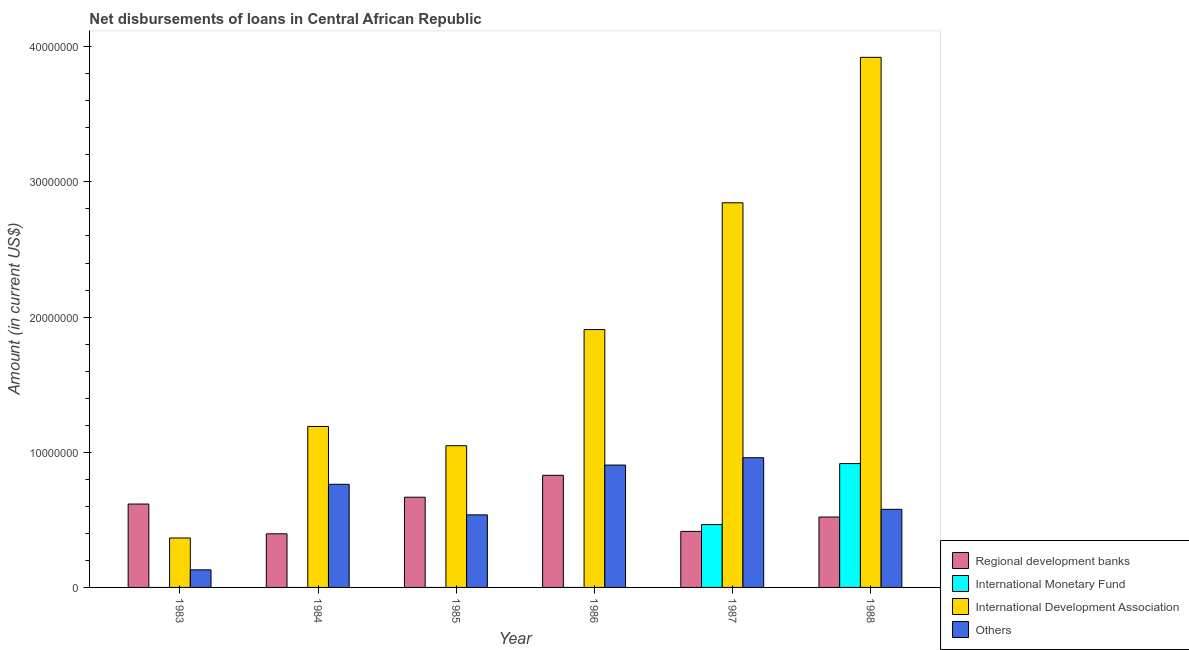Are the number of bars per tick equal to the number of legend labels?
Your answer should be very brief. No. Are the number of bars on each tick of the X-axis equal?
Ensure brevity in your answer.  No. How many bars are there on the 4th tick from the right?
Offer a terse response. 3. In how many cases, is the number of bars for a given year not equal to the number of legend labels?
Provide a succinct answer. 4. What is the amount of loan disimbursed by regional development banks in 1985?
Make the answer very short. 6.67e+06. Across all years, what is the maximum amount of loan disimbursed by other organisations?
Make the answer very short. 9.60e+06. In which year was the amount of loan disimbursed by other organisations maximum?
Your answer should be compact. 1987. What is the total amount of loan disimbursed by international monetary fund in the graph?
Ensure brevity in your answer.  1.38e+07. What is the difference between the amount of loan disimbursed by other organisations in 1984 and that in 1987?
Offer a terse response. -1.97e+06. What is the difference between the amount of loan disimbursed by international monetary fund in 1986 and the amount of loan disimbursed by regional development banks in 1987?
Provide a short and direct response. -4.65e+06. What is the average amount of loan disimbursed by international development association per year?
Keep it short and to the point. 1.88e+07. In the year 1985, what is the difference between the amount of loan disimbursed by other organisations and amount of loan disimbursed by regional development banks?
Ensure brevity in your answer.  0. In how many years, is the amount of loan disimbursed by international development association greater than 38000000 US$?
Make the answer very short. 1. What is the ratio of the amount of loan disimbursed by other organisations in 1984 to that in 1985?
Offer a terse response. 1.42. Is the amount of loan disimbursed by regional development banks in 1986 less than that in 1987?
Give a very brief answer. No. Is the difference between the amount of loan disimbursed by regional development banks in 1983 and 1988 greater than the difference between the amount of loan disimbursed by other organisations in 1983 and 1988?
Offer a very short reply. No. What is the difference between the highest and the second highest amount of loan disimbursed by regional development banks?
Provide a succinct answer. 1.62e+06. What is the difference between the highest and the lowest amount of loan disimbursed by international development association?
Your answer should be compact. 3.56e+07. Is the sum of the amount of loan disimbursed by international development association in 1984 and 1988 greater than the maximum amount of loan disimbursed by other organisations across all years?
Your answer should be very brief. Yes. How many bars are there?
Your response must be concise. 20. Are the values on the major ticks of Y-axis written in scientific E-notation?
Your answer should be compact. No. Does the graph contain grids?
Your response must be concise. No. Where does the legend appear in the graph?
Provide a short and direct response. Bottom right. What is the title of the graph?
Provide a succinct answer. Net disbursements of loans in Central African Republic. What is the label or title of the X-axis?
Give a very brief answer. Year. What is the label or title of the Y-axis?
Your response must be concise. Amount (in current US$). What is the Amount (in current US$) of Regional development banks in 1983?
Ensure brevity in your answer.  6.17e+06. What is the Amount (in current US$) of International Monetary Fund in 1983?
Your response must be concise. 0. What is the Amount (in current US$) of International Development Association in 1983?
Provide a succinct answer. 3.66e+06. What is the Amount (in current US$) of Others in 1983?
Your answer should be compact. 1.30e+06. What is the Amount (in current US$) in Regional development banks in 1984?
Offer a terse response. 3.97e+06. What is the Amount (in current US$) in International Development Association in 1984?
Make the answer very short. 1.19e+07. What is the Amount (in current US$) in Others in 1984?
Provide a succinct answer. 7.63e+06. What is the Amount (in current US$) in Regional development banks in 1985?
Your answer should be compact. 6.67e+06. What is the Amount (in current US$) in International Monetary Fund in 1985?
Ensure brevity in your answer.  0. What is the Amount (in current US$) of International Development Association in 1985?
Your answer should be very brief. 1.05e+07. What is the Amount (in current US$) in Others in 1985?
Provide a short and direct response. 5.37e+06. What is the Amount (in current US$) in Regional development banks in 1986?
Offer a very short reply. 8.30e+06. What is the Amount (in current US$) in International Development Association in 1986?
Make the answer very short. 1.91e+07. What is the Amount (in current US$) of Others in 1986?
Offer a terse response. 9.05e+06. What is the Amount (in current US$) in Regional development banks in 1987?
Make the answer very short. 4.15e+06. What is the Amount (in current US$) of International Monetary Fund in 1987?
Give a very brief answer. 4.65e+06. What is the Amount (in current US$) of International Development Association in 1987?
Give a very brief answer. 2.85e+07. What is the Amount (in current US$) of Others in 1987?
Provide a succinct answer. 9.60e+06. What is the Amount (in current US$) of Regional development banks in 1988?
Provide a succinct answer. 5.21e+06. What is the Amount (in current US$) of International Monetary Fund in 1988?
Your answer should be compact. 9.16e+06. What is the Amount (in current US$) of International Development Association in 1988?
Make the answer very short. 3.92e+07. What is the Amount (in current US$) in Others in 1988?
Offer a very short reply. 5.78e+06. Across all years, what is the maximum Amount (in current US$) in Regional development banks?
Offer a very short reply. 8.30e+06. Across all years, what is the maximum Amount (in current US$) in International Monetary Fund?
Your response must be concise. 9.16e+06. Across all years, what is the maximum Amount (in current US$) of International Development Association?
Give a very brief answer. 3.92e+07. Across all years, what is the maximum Amount (in current US$) in Others?
Provide a succinct answer. 9.60e+06. Across all years, what is the minimum Amount (in current US$) in Regional development banks?
Offer a terse response. 3.97e+06. Across all years, what is the minimum Amount (in current US$) of International Monetary Fund?
Provide a succinct answer. 0. Across all years, what is the minimum Amount (in current US$) in International Development Association?
Offer a very short reply. 3.66e+06. Across all years, what is the minimum Amount (in current US$) of Others?
Your response must be concise. 1.30e+06. What is the total Amount (in current US$) in Regional development banks in the graph?
Keep it short and to the point. 3.45e+07. What is the total Amount (in current US$) in International Monetary Fund in the graph?
Your response must be concise. 1.38e+07. What is the total Amount (in current US$) of International Development Association in the graph?
Ensure brevity in your answer.  1.13e+08. What is the total Amount (in current US$) in Others in the graph?
Offer a very short reply. 3.87e+07. What is the difference between the Amount (in current US$) in Regional development banks in 1983 and that in 1984?
Your answer should be very brief. 2.20e+06. What is the difference between the Amount (in current US$) in International Development Association in 1983 and that in 1984?
Your answer should be very brief. -8.25e+06. What is the difference between the Amount (in current US$) of Others in 1983 and that in 1984?
Make the answer very short. -6.33e+06. What is the difference between the Amount (in current US$) in Regional development banks in 1983 and that in 1985?
Provide a succinct answer. -5.05e+05. What is the difference between the Amount (in current US$) of International Development Association in 1983 and that in 1985?
Keep it short and to the point. -6.83e+06. What is the difference between the Amount (in current US$) of Others in 1983 and that in 1985?
Give a very brief answer. -4.07e+06. What is the difference between the Amount (in current US$) in Regional development banks in 1983 and that in 1986?
Make the answer very short. -2.13e+06. What is the difference between the Amount (in current US$) in International Development Association in 1983 and that in 1986?
Make the answer very short. -1.54e+07. What is the difference between the Amount (in current US$) in Others in 1983 and that in 1986?
Give a very brief answer. -7.75e+06. What is the difference between the Amount (in current US$) of Regional development banks in 1983 and that in 1987?
Provide a succinct answer. 2.02e+06. What is the difference between the Amount (in current US$) in International Development Association in 1983 and that in 1987?
Offer a very short reply. -2.48e+07. What is the difference between the Amount (in current US$) in Others in 1983 and that in 1987?
Offer a terse response. -8.29e+06. What is the difference between the Amount (in current US$) of Regional development banks in 1983 and that in 1988?
Make the answer very short. 9.61e+05. What is the difference between the Amount (in current US$) of International Development Association in 1983 and that in 1988?
Provide a succinct answer. -3.56e+07. What is the difference between the Amount (in current US$) in Others in 1983 and that in 1988?
Your answer should be very brief. -4.48e+06. What is the difference between the Amount (in current US$) of Regional development banks in 1984 and that in 1985?
Offer a very short reply. -2.71e+06. What is the difference between the Amount (in current US$) in International Development Association in 1984 and that in 1985?
Make the answer very short. 1.42e+06. What is the difference between the Amount (in current US$) of Others in 1984 and that in 1985?
Your response must be concise. 2.26e+06. What is the difference between the Amount (in current US$) of Regional development banks in 1984 and that in 1986?
Ensure brevity in your answer.  -4.33e+06. What is the difference between the Amount (in current US$) of International Development Association in 1984 and that in 1986?
Ensure brevity in your answer.  -7.17e+06. What is the difference between the Amount (in current US$) in Others in 1984 and that in 1986?
Provide a succinct answer. -1.42e+06. What is the difference between the Amount (in current US$) of Regional development banks in 1984 and that in 1987?
Provide a succinct answer. -1.79e+05. What is the difference between the Amount (in current US$) in International Development Association in 1984 and that in 1987?
Provide a succinct answer. -1.65e+07. What is the difference between the Amount (in current US$) of Others in 1984 and that in 1987?
Offer a very short reply. -1.97e+06. What is the difference between the Amount (in current US$) in Regional development banks in 1984 and that in 1988?
Ensure brevity in your answer.  -1.24e+06. What is the difference between the Amount (in current US$) in International Development Association in 1984 and that in 1988?
Ensure brevity in your answer.  -2.73e+07. What is the difference between the Amount (in current US$) of Others in 1984 and that in 1988?
Give a very brief answer. 1.85e+06. What is the difference between the Amount (in current US$) in Regional development banks in 1985 and that in 1986?
Ensure brevity in your answer.  -1.62e+06. What is the difference between the Amount (in current US$) in International Development Association in 1985 and that in 1986?
Provide a succinct answer. -8.59e+06. What is the difference between the Amount (in current US$) of Others in 1985 and that in 1986?
Your answer should be very brief. -3.68e+06. What is the difference between the Amount (in current US$) of Regional development banks in 1985 and that in 1987?
Your response must be concise. 2.53e+06. What is the difference between the Amount (in current US$) of International Development Association in 1985 and that in 1987?
Your response must be concise. -1.80e+07. What is the difference between the Amount (in current US$) in Others in 1985 and that in 1987?
Offer a very short reply. -4.23e+06. What is the difference between the Amount (in current US$) in Regional development banks in 1985 and that in 1988?
Give a very brief answer. 1.47e+06. What is the difference between the Amount (in current US$) of International Development Association in 1985 and that in 1988?
Make the answer very short. -2.87e+07. What is the difference between the Amount (in current US$) of Others in 1985 and that in 1988?
Provide a short and direct response. -4.10e+05. What is the difference between the Amount (in current US$) in Regional development banks in 1986 and that in 1987?
Offer a terse response. 4.15e+06. What is the difference between the Amount (in current US$) of International Development Association in 1986 and that in 1987?
Ensure brevity in your answer.  -9.38e+06. What is the difference between the Amount (in current US$) of Others in 1986 and that in 1987?
Make the answer very short. -5.42e+05. What is the difference between the Amount (in current US$) of Regional development banks in 1986 and that in 1988?
Your answer should be very brief. 3.09e+06. What is the difference between the Amount (in current US$) of International Development Association in 1986 and that in 1988?
Provide a succinct answer. -2.01e+07. What is the difference between the Amount (in current US$) of Others in 1986 and that in 1988?
Keep it short and to the point. 3.28e+06. What is the difference between the Amount (in current US$) in Regional development banks in 1987 and that in 1988?
Make the answer very short. -1.06e+06. What is the difference between the Amount (in current US$) in International Monetary Fund in 1987 and that in 1988?
Provide a succinct answer. -4.51e+06. What is the difference between the Amount (in current US$) in International Development Association in 1987 and that in 1988?
Provide a succinct answer. -1.08e+07. What is the difference between the Amount (in current US$) of Others in 1987 and that in 1988?
Your answer should be very brief. 3.82e+06. What is the difference between the Amount (in current US$) of Regional development banks in 1983 and the Amount (in current US$) of International Development Association in 1984?
Ensure brevity in your answer.  -5.74e+06. What is the difference between the Amount (in current US$) of Regional development banks in 1983 and the Amount (in current US$) of Others in 1984?
Make the answer very short. -1.46e+06. What is the difference between the Amount (in current US$) of International Development Association in 1983 and the Amount (in current US$) of Others in 1984?
Your answer should be very brief. -3.97e+06. What is the difference between the Amount (in current US$) in Regional development banks in 1983 and the Amount (in current US$) in International Development Association in 1985?
Keep it short and to the point. -4.32e+06. What is the difference between the Amount (in current US$) of Regional development banks in 1983 and the Amount (in current US$) of Others in 1985?
Ensure brevity in your answer.  8.01e+05. What is the difference between the Amount (in current US$) of International Development Association in 1983 and the Amount (in current US$) of Others in 1985?
Provide a succinct answer. -1.71e+06. What is the difference between the Amount (in current US$) of Regional development banks in 1983 and the Amount (in current US$) of International Development Association in 1986?
Offer a very short reply. -1.29e+07. What is the difference between the Amount (in current US$) in Regional development banks in 1983 and the Amount (in current US$) in Others in 1986?
Provide a succinct answer. -2.88e+06. What is the difference between the Amount (in current US$) of International Development Association in 1983 and the Amount (in current US$) of Others in 1986?
Ensure brevity in your answer.  -5.40e+06. What is the difference between the Amount (in current US$) in Regional development banks in 1983 and the Amount (in current US$) in International Monetary Fund in 1987?
Provide a short and direct response. 1.52e+06. What is the difference between the Amount (in current US$) of Regional development banks in 1983 and the Amount (in current US$) of International Development Association in 1987?
Ensure brevity in your answer.  -2.23e+07. What is the difference between the Amount (in current US$) in Regional development banks in 1983 and the Amount (in current US$) in Others in 1987?
Provide a short and direct response. -3.43e+06. What is the difference between the Amount (in current US$) of International Development Association in 1983 and the Amount (in current US$) of Others in 1987?
Keep it short and to the point. -5.94e+06. What is the difference between the Amount (in current US$) in Regional development banks in 1983 and the Amount (in current US$) in International Monetary Fund in 1988?
Give a very brief answer. -2.99e+06. What is the difference between the Amount (in current US$) in Regional development banks in 1983 and the Amount (in current US$) in International Development Association in 1988?
Your answer should be very brief. -3.30e+07. What is the difference between the Amount (in current US$) of Regional development banks in 1983 and the Amount (in current US$) of Others in 1988?
Make the answer very short. 3.91e+05. What is the difference between the Amount (in current US$) in International Development Association in 1983 and the Amount (in current US$) in Others in 1988?
Give a very brief answer. -2.12e+06. What is the difference between the Amount (in current US$) in Regional development banks in 1984 and the Amount (in current US$) in International Development Association in 1985?
Keep it short and to the point. -6.52e+06. What is the difference between the Amount (in current US$) of Regional development banks in 1984 and the Amount (in current US$) of Others in 1985?
Your answer should be compact. -1.40e+06. What is the difference between the Amount (in current US$) in International Development Association in 1984 and the Amount (in current US$) in Others in 1985?
Ensure brevity in your answer.  6.54e+06. What is the difference between the Amount (in current US$) in Regional development banks in 1984 and the Amount (in current US$) in International Development Association in 1986?
Offer a very short reply. -1.51e+07. What is the difference between the Amount (in current US$) of Regional development banks in 1984 and the Amount (in current US$) of Others in 1986?
Ensure brevity in your answer.  -5.09e+06. What is the difference between the Amount (in current US$) of International Development Association in 1984 and the Amount (in current US$) of Others in 1986?
Offer a terse response. 2.85e+06. What is the difference between the Amount (in current US$) in Regional development banks in 1984 and the Amount (in current US$) in International Monetary Fund in 1987?
Provide a succinct answer. -6.81e+05. What is the difference between the Amount (in current US$) of Regional development banks in 1984 and the Amount (in current US$) of International Development Association in 1987?
Your answer should be compact. -2.45e+07. What is the difference between the Amount (in current US$) of Regional development banks in 1984 and the Amount (in current US$) of Others in 1987?
Make the answer very short. -5.63e+06. What is the difference between the Amount (in current US$) of International Development Association in 1984 and the Amount (in current US$) of Others in 1987?
Your response must be concise. 2.31e+06. What is the difference between the Amount (in current US$) of Regional development banks in 1984 and the Amount (in current US$) of International Monetary Fund in 1988?
Provide a short and direct response. -5.19e+06. What is the difference between the Amount (in current US$) of Regional development banks in 1984 and the Amount (in current US$) of International Development Association in 1988?
Keep it short and to the point. -3.52e+07. What is the difference between the Amount (in current US$) of Regional development banks in 1984 and the Amount (in current US$) of Others in 1988?
Offer a terse response. -1.81e+06. What is the difference between the Amount (in current US$) of International Development Association in 1984 and the Amount (in current US$) of Others in 1988?
Provide a succinct answer. 6.13e+06. What is the difference between the Amount (in current US$) of Regional development banks in 1985 and the Amount (in current US$) of International Development Association in 1986?
Offer a very short reply. -1.24e+07. What is the difference between the Amount (in current US$) in Regional development banks in 1985 and the Amount (in current US$) in Others in 1986?
Provide a short and direct response. -2.38e+06. What is the difference between the Amount (in current US$) of International Development Association in 1985 and the Amount (in current US$) of Others in 1986?
Your answer should be compact. 1.43e+06. What is the difference between the Amount (in current US$) of Regional development banks in 1985 and the Amount (in current US$) of International Monetary Fund in 1987?
Offer a terse response. 2.03e+06. What is the difference between the Amount (in current US$) of Regional development banks in 1985 and the Amount (in current US$) of International Development Association in 1987?
Provide a short and direct response. -2.18e+07. What is the difference between the Amount (in current US$) of Regional development banks in 1985 and the Amount (in current US$) of Others in 1987?
Your answer should be very brief. -2.92e+06. What is the difference between the Amount (in current US$) of International Development Association in 1985 and the Amount (in current US$) of Others in 1987?
Provide a succinct answer. 8.89e+05. What is the difference between the Amount (in current US$) of Regional development banks in 1985 and the Amount (in current US$) of International Monetary Fund in 1988?
Your answer should be very brief. -2.49e+06. What is the difference between the Amount (in current US$) of Regional development banks in 1985 and the Amount (in current US$) of International Development Association in 1988?
Offer a terse response. -3.25e+07. What is the difference between the Amount (in current US$) in Regional development banks in 1985 and the Amount (in current US$) in Others in 1988?
Ensure brevity in your answer.  8.96e+05. What is the difference between the Amount (in current US$) in International Development Association in 1985 and the Amount (in current US$) in Others in 1988?
Provide a succinct answer. 4.71e+06. What is the difference between the Amount (in current US$) of Regional development banks in 1986 and the Amount (in current US$) of International Monetary Fund in 1987?
Give a very brief answer. 3.65e+06. What is the difference between the Amount (in current US$) in Regional development banks in 1986 and the Amount (in current US$) in International Development Association in 1987?
Your response must be concise. -2.02e+07. What is the difference between the Amount (in current US$) of Regional development banks in 1986 and the Amount (in current US$) of Others in 1987?
Your answer should be compact. -1.30e+06. What is the difference between the Amount (in current US$) in International Development Association in 1986 and the Amount (in current US$) in Others in 1987?
Offer a very short reply. 9.48e+06. What is the difference between the Amount (in current US$) in Regional development banks in 1986 and the Amount (in current US$) in International Monetary Fund in 1988?
Offer a very short reply. -8.66e+05. What is the difference between the Amount (in current US$) in Regional development banks in 1986 and the Amount (in current US$) in International Development Association in 1988?
Ensure brevity in your answer.  -3.09e+07. What is the difference between the Amount (in current US$) of Regional development banks in 1986 and the Amount (in current US$) of Others in 1988?
Provide a succinct answer. 2.52e+06. What is the difference between the Amount (in current US$) of International Development Association in 1986 and the Amount (in current US$) of Others in 1988?
Give a very brief answer. 1.33e+07. What is the difference between the Amount (in current US$) in Regional development banks in 1987 and the Amount (in current US$) in International Monetary Fund in 1988?
Keep it short and to the point. -5.02e+06. What is the difference between the Amount (in current US$) in Regional development banks in 1987 and the Amount (in current US$) in International Development Association in 1988?
Offer a terse response. -3.51e+07. What is the difference between the Amount (in current US$) in Regional development banks in 1987 and the Amount (in current US$) in Others in 1988?
Provide a succinct answer. -1.63e+06. What is the difference between the Amount (in current US$) of International Monetary Fund in 1987 and the Amount (in current US$) of International Development Association in 1988?
Make the answer very short. -3.46e+07. What is the difference between the Amount (in current US$) in International Monetary Fund in 1987 and the Amount (in current US$) in Others in 1988?
Provide a short and direct response. -1.13e+06. What is the difference between the Amount (in current US$) in International Development Association in 1987 and the Amount (in current US$) in Others in 1988?
Your response must be concise. 2.27e+07. What is the average Amount (in current US$) of Regional development banks per year?
Keep it short and to the point. 5.74e+06. What is the average Amount (in current US$) of International Monetary Fund per year?
Offer a terse response. 2.30e+06. What is the average Amount (in current US$) in International Development Association per year?
Provide a short and direct response. 1.88e+07. What is the average Amount (in current US$) of Others per year?
Ensure brevity in your answer.  6.45e+06. In the year 1983, what is the difference between the Amount (in current US$) in Regional development banks and Amount (in current US$) in International Development Association?
Ensure brevity in your answer.  2.51e+06. In the year 1983, what is the difference between the Amount (in current US$) of Regional development banks and Amount (in current US$) of Others?
Provide a short and direct response. 4.87e+06. In the year 1983, what is the difference between the Amount (in current US$) of International Development Association and Amount (in current US$) of Others?
Provide a succinct answer. 2.36e+06. In the year 1984, what is the difference between the Amount (in current US$) of Regional development banks and Amount (in current US$) of International Development Association?
Ensure brevity in your answer.  -7.94e+06. In the year 1984, what is the difference between the Amount (in current US$) in Regional development banks and Amount (in current US$) in Others?
Offer a terse response. -3.66e+06. In the year 1984, what is the difference between the Amount (in current US$) in International Development Association and Amount (in current US$) in Others?
Your answer should be compact. 4.28e+06. In the year 1985, what is the difference between the Amount (in current US$) of Regional development banks and Amount (in current US$) of International Development Association?
Offer a terse response. -3.81e+06. In the year 1985, what is the difference between the Amount (in current US$) in Regional development banks and Amount (in current US$) in Others?
Ensure brevity in your answer.  1.31e+06. In the year 1985, what is the difference between the Amount (in current US$) in International Development Association and Amount (in current US$) in Others?
Provide a short and direct response. 5.12e+06. In the year 1986, what is the difference between the Amount (in current US$) of Regional development banks and Amount (in current US$) of International Development Association?
Provide a succinct answer. -1.08e+07. In the year 1986, what is the difference between the Amount (in current US$) in Regional development banks and Amount (in current US$) in Others?
Keep it short and to the point. -7.58e+05. In the year 1986, what is the difference between the Amount (in current US$) in International Development Association and Amount (in current US$) in Others?
Your answer should be very brief. 1.00e+07. In the year 1987, what is the difference between the Amount (in current US$) of Regional development banks and Amount (in current US$) of International Monetary Fund?
Make the answer very short. -5.02e+05. In the year 1987, what is the difference between the Amount (in current US$) of Regional development banks and Amount (in current US$) of International Development Association?
Provide a short and direct response. -2.43e+07. In the year 1987, what is the difference between the Amount (in current US$) in Regional development banks and Amount (in current US$) in Others?
Make the answer very short. -5.45e+06. In the year 1987, what is the difference between the Amount (in current US$) of International Monetary Fund and Amount (in current US$) of International Development Association?
Ensure brevity in your answer.  -2.38e+07. In the year 1987, what is the difference between the Amount (in current US$) of International Monetary Fund and Amount (in current US$) of Others?
Provide a short and direct response. -4.95e+06. In the year 1987, what is the difference between the Amount (in current US$) in International Development Association and Amount (in current US$) in Others?
Your answer should be compact. 1.89e+07. In the year 1988, what is the difference between the Amount (in current US$) in Regional development banks and Amount (in current US$) in International Monetary Fund?
Your response must be concise. -3.95e+06. In the year 1988, what is the difference between the Amount (in current US$) in Regional development banks and Amount (in current US$) in International Development Association?
Give a very brief answer. -3.40e+07. In the year 1988, what is the difference between the Amount (in current US$) of Regional development banks and Amount (in current US$) of Others?
Your answer should be compact. -5.70e+05. In the year 1988, what is the difference between the Amount (in current US$) in International Monetary Fund and Amount (in current US$) in International Development Association?
Your response must be concise. -3.01e+07. In the year 1988, what is the difference between the Amount (in current US$) of International Monetary Fund and Amount (in current US$) of Others?
Make the answer very short. 3.38e+06. In the year 1988, what is the difference between the Amount (in current US$) in International Development Association and Amount (in current US$) in Others?
Provide a succinct answer. 3.34e+07. What is the ratio of the Amount (in current US$) in Regional development banks in 1983 to that in 1984?
Give a very brief answer. 1.56. What is the ratio of the Amount (in current US$) of International Development Association in 1983 to that in 1984?
Offer a terse response. 0.31. What is the ratio of the Amount (in current US$) of Others in 1983 to that in 1984?
Provide a short and direct response. 0.17. What is the ratio of the Amount (in current US$) in Regional development banks in 1983 to that in 1985?
Provide a succinct answer. 0.92. What is the ratio of the Amount (in current US$) in International Development Association in 1983 to that in 1985?
Your answer should be compact. 0.35. What is the ratio of the Amount (in current US$) in Others in 1983 to that in 1985?
Your response must be concise. 0.24. What is the ratio of the Amount (in current US$) of Regional development banks in 1983 to that in 1986?
Your response must be concise. 0.74. What is the ratio of the Amount (in current US$) in International Development Association in 1983 to that in 1986?
Provide a succinct answer. 0.19. What is the ratio of the Amount (in current US$) of Others in 1983 to that in 1986?
Your answer should be compact. 0.14. What is the ratio of the Amount (in current US$) in Regional development banks in 1983 to that in 1987?
Your answer should be compact. 1.49. What is the ratio of the Amount (in current US$) in International Development Association in 1983 to that in 1987?
Provide a short and direct response. 0.13. What is the ratio of the Amount (in current US$) of Others in 1983 to that in 1987?
Your answer should be very brief. 0.14. What is the ratio of the Amount (in current US$) in Regional development banks in 1983 to that in 1988?
Ensure brevity in your answer.  1.18. What is the ratio of the Amount (in current US$) of International Development Association in 1983 to that in 1988?
Your answer should be very brief. 0.09. What is the ratio of the Amount (in current US$) of Others in 1983 to that in 1988?
Your answer should be compact. 0.23. What is the ratio of the Amount (in current US$) of Regional development banks in 1984 to that in 1985?
Provide a short and direct response. 0.59. What is the ratio of the Amount (in current US$) in International Development Association in 1984 to that in 1985?
Offer a terse response. 1.14. What is the ratio of the Amount (in current US$) of Others in 1984 to that in 1985?
Your response must be concise. 1.42. What is the ratio of the Amount (in current US$) of Regional development banks in 1984 to that in 1986?
Offer a very short reply. 0.48. What is the ratio of the Amount (in current US$) in International Development Association in 1984 to that in 1986?
Make the answer very short. 0.62. What is the ratio of the Amount (in current US$) of Others in 1984 to that in 1986?
Offer a terse response. 0.84. What is the ratio of the Amount (in current US$) of Regional development banks in 1984 to that in 1987?
Ensure brevity in your answer.  0.96. What is the ratio of the Amount (in current US$) in International Development Association in 1984 to that in 1987?
Your answer should be very brief. 0.42. What is the ratio of the Amount (in current US$) in Others in 1984 to that in 1987?
Provide a short and direct response. 0.8. What is the ratio of the Amount (in current US$) in Regional development banks in 1984 to that in 1988?
Ensure brevity in your answer.  0.76. What is the ratio of the Amount (in current US$) in International Development Association in 1984 to that in 1988?
Your response must be concise. 0.3. What is the ratio of the Amount (in current US$) in Others in 1984 to that in 1988?
Keep it short and to the point. 1.32. What is the ratio of the Amount (in current US$) in Regional development banks in 1985 to that in 1986?
Provide a short and direct response. 0.8. What is the ratio of the Amount (in current US$) of International Development Association in 1985 to that in 1986?
Provide a short and direct response. 0.55. What is the ratio of the Amount (in current US$) in Others in 1985 to that in 1986?
Offer a terse response. 0.59. What is the ratio of the Amount (in current US$) in Regional development banks in 1985 to that in 1987?
Your answer should be very brief. 1.61. What is the ratio of the Amount (in current US$) in International Development Association in 1985 to that in 1987?
Your answer should be very brief. 0.37. What is the ratio of the Amount (in current US$) of Others in 1985 to that in 1987?
Provide a short and direct response. 0.56. What is the ratio of the Amount (in current US$) of Regional development banks in 1985 to that in 1988?
Offer a terse response. 1.28. What is the ratio of the Amount (in current US$) of International Development Association in 1985 to that in 1988?
Your answer should be compact. 0.27. What is the ratio of the Amount (in current US$) in Others in 1985 to that in 1988?
Ensure brevity in your answer.  0.93. What is the ratio of the Amount (in current US$) in Regional development banks in 1986 to that in 1987?
Provide a short and direct response. 2. What is the ratio of the Amount (in current US$) of International Development Association in 1986 to that in 1987?
Make the answer very short. 0.67. What is the ratio of the Amount (in current US$) in Others in 1986 to that in 1987?
Give a very brief answer. 0.94. What is the ratio of the Amount (in current US$) in Regional development banks in 1986 to that in 1988?
Your response must be concise. 1.59. What is the ratio of the Amount (in current US$) in International Development Association in 1986 to that in 1988?
Provide a short and direct response. 0.49. What is the ratio of the Amount (in current US$) of Others in 1986 to that in 1988?
Your response must be concise. 1.57. What is the ratio of the Amount (in current US$) in Regional development banks in 1987 to that in 1988?
Ensure brevity in your answer.  0.8. What is the ratio of the Amount (in current US$) of International Monetary Fund in 1987 to that in 1988?
Provide a short and direct response. 0.51. What is the ratio of the Amount (in current US$) of International Development Association in 1987 to that in 1988?
Provide a short and direct response. 0.73. What is the ratio of the Amount (in current US$) in Others in 1987 to that in 1988?
Offer a terse response. 1.66. What is the difference between the highest and the second highest Amount (in current US$) in Regional development banks?
Provide a succinct answer. 1.62e+06. What is the difference between the highest and the second highest Amount (in current US$) in International Development Association?
Provide a succinct answer. 1.08e+07. What is the difference between the highest and the second highest Amount (in current US$) of Others?
Your answer should be compact. 5.42e+05. What is the difference between the highest and the lowest Amount (in current US$) of Regional development banks?
Provide a short and direct response. 4.33e+06. What is the difference between the highest and the lowest Amount (in current US$) in International Monetary Fund?
Ensure brevity in your answer.  9.16e+06. What is the difference between the highest and the lowest Amount (in current US$) in International Development Association?
Offer a terse response. 3.56e+07. What is the difference between the highest and the lowest Amount (in current US$) of Others?
Your answer should be compact. 8.29e+06. 